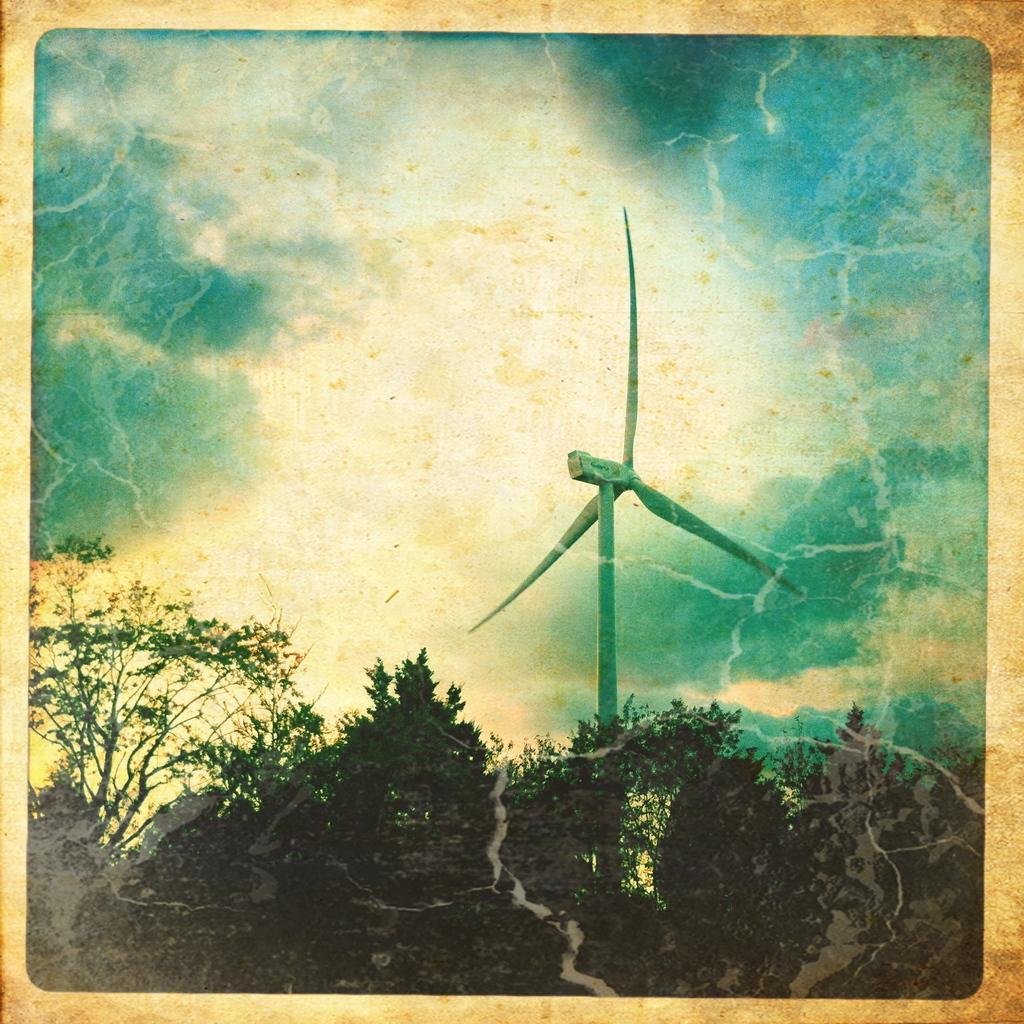Can you describe this image briefly? In this image, there is a photo of a picture. In this picture, there are some trees at the bottom of the image. There is a windmill in the middle of the image. In the background, there is a sky. 